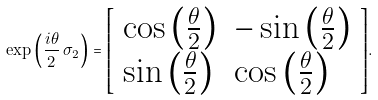Convert formula to latex. <formula><loc_0><loc_0><loc_500><loc_500>\exp \left ( { \frac { i \theta } { 2 } } \, \sigma _ { 2 } \right ) = { \left [ \begin{array} { l l } { \cos \left ( { \frac { \theta } { 2 } } \right ) } & { - \sin \left ( { \frac { \theta } { 2 } } \right ) } \\ { \sin \left ( { \frac { \theta } { 2 } } \right ) } & { \cos \left ( { \frac { \theta } { 2 } } \right ) } \end{array} \right ] } .</formula> 